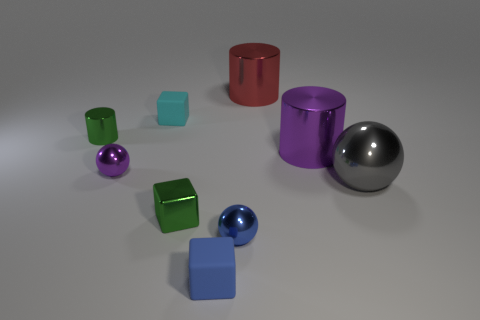Add 1 green shiny blocks. How many objects exist? 10 Subtract all balls. How many objects are left? 6 Add 8 big gray metallic balls. How many big gray metallic balls are left? 9 Add 8 purple metallic cylinders. How many purple metallic cylinders exist? 9 Subtract 1 gray balls. How many objects are left? 8 Subtract all small matte cubes. Subtract all cyan rubber blocks. How many objects are left? 6 